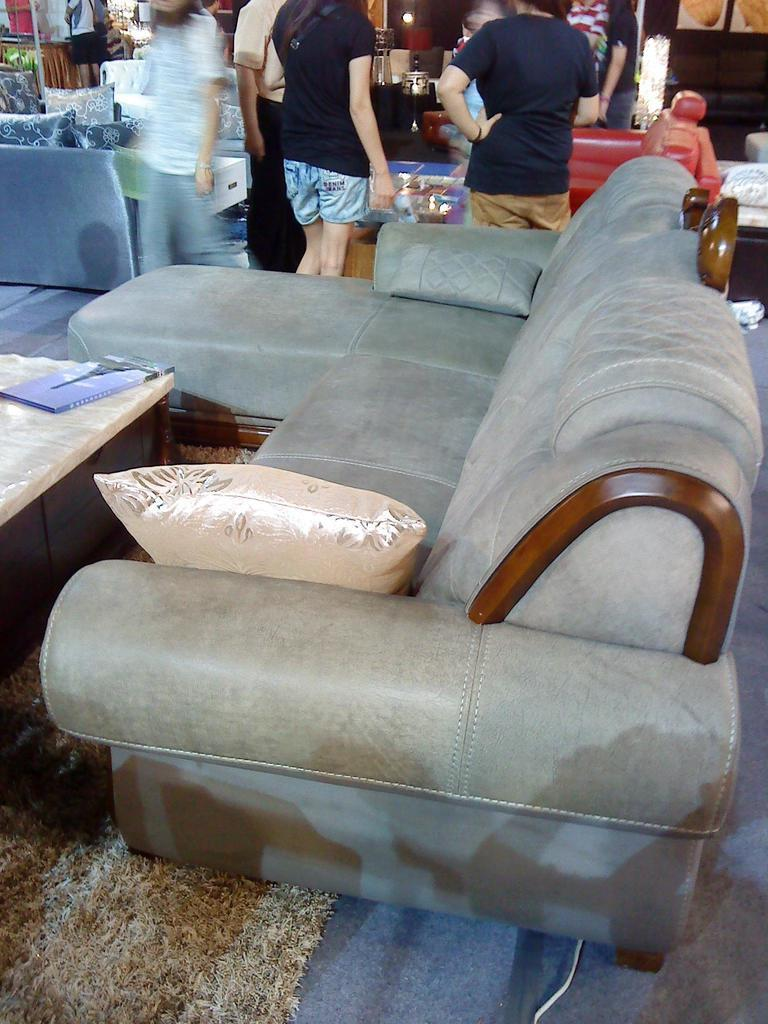What type of furniture is in the image? There is a couch in the image. Is there anything on the couch? Yes, there is a pillow on the couch. What animal can be seen sneezing on the couch in the image? There is no animal present in the image, nor is there any sneezing. 